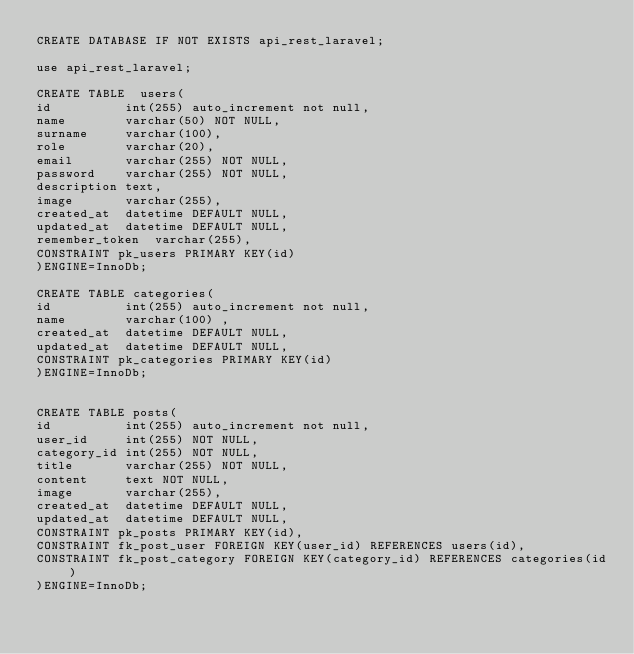<code> <loc_0><loc_0><loc_500><loc_500><_SQL_>CREATE DATABASE IF NOT EXISTS api_rest_laravel;

use api_rest_laravel;

CREATE TABLE  users(
id 			int(255) auto_increment not null,
name		varchar(50) NOT NULL,
surname		varchar(100),
role		varchar(20),
email		varchar(255) NOT NULL,
password	varchar(255) NOT NULL,
description	text,
image		varchar(255),
created_at	datetime DEFAULT NULL,
updated_at	datetime DEFAULT NULL,
remember_token	varchar(255),
CONSTRAINT pk_users PRIMARY KEY(id)
)ENGINE=InnoDb;

CREATE TABLE categories(
id 			int(255) auto_increment not null,
name		varchar(100) ,
created_at	datetime DEFAULT NULL,
updated_at	datetime DEFAULT NULL,
CONSTRAINT pk_categories PRIMARY KEY(id)
)ENGINE=InnoDb;


CREATE TABLE posts(
id 			int(255) auto_increment not null,
user_id		int(255) NOT NULL,
category_id int(255) NOT NULL,
title 		varchar(255) NOT NULL,
content 	text NOT NULL,
image		varchar(255),
created_at	datetime DEFAULT NULL,
updated_at	datetime DEFAULT NULL,
CONSTRAINT pk_posts PRIMARY KEY(id),
CONSTRAINT fk_post_user FOREIGN KEY(user_id) REFERENCES users(id),
CONSTRAINT fk_post_category FOREIGN KEY(category_id) REFERENCES categories(id) 
)ENGINE=InnoDb;</code> 